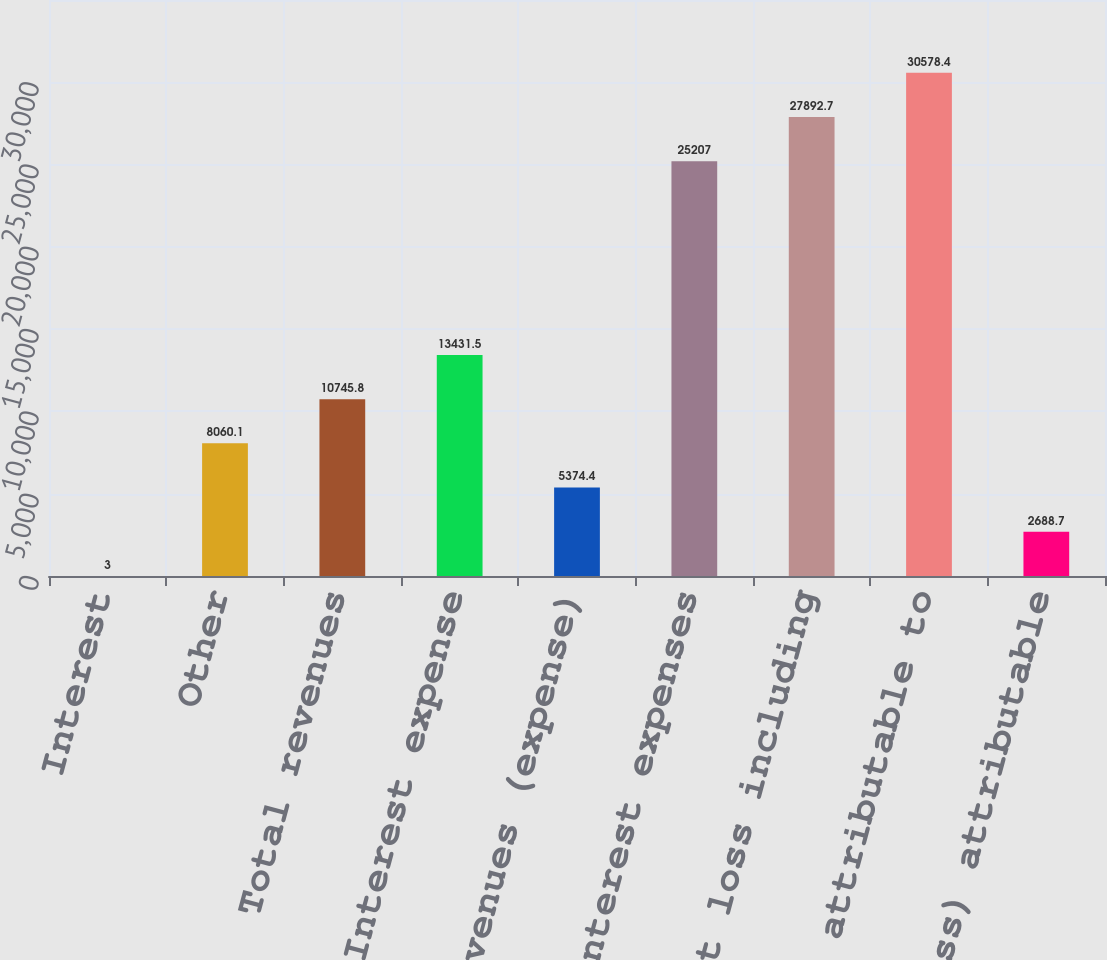Convert chart to OTSL. <chart><loc_0><loc_0><loc_500><loc_500><bar_chart><fcel>Interest<fcel>Other<fcel>Total revenues<fcel>Interest expense<fcel>Net revenues (expense)<fcel>Non-interest expenses<fcel>Net loss including<fcel>Net loss attributable to<fcel>Net income (loss) attributable<nl><fcel>3<fcel>8060.1<fcel>10745.8<fcel>13431.5<fcel>5374.4<fcel>25207<fcel>27892.7<fcel>30578.4<fcel>2688.7<nl></chart> 